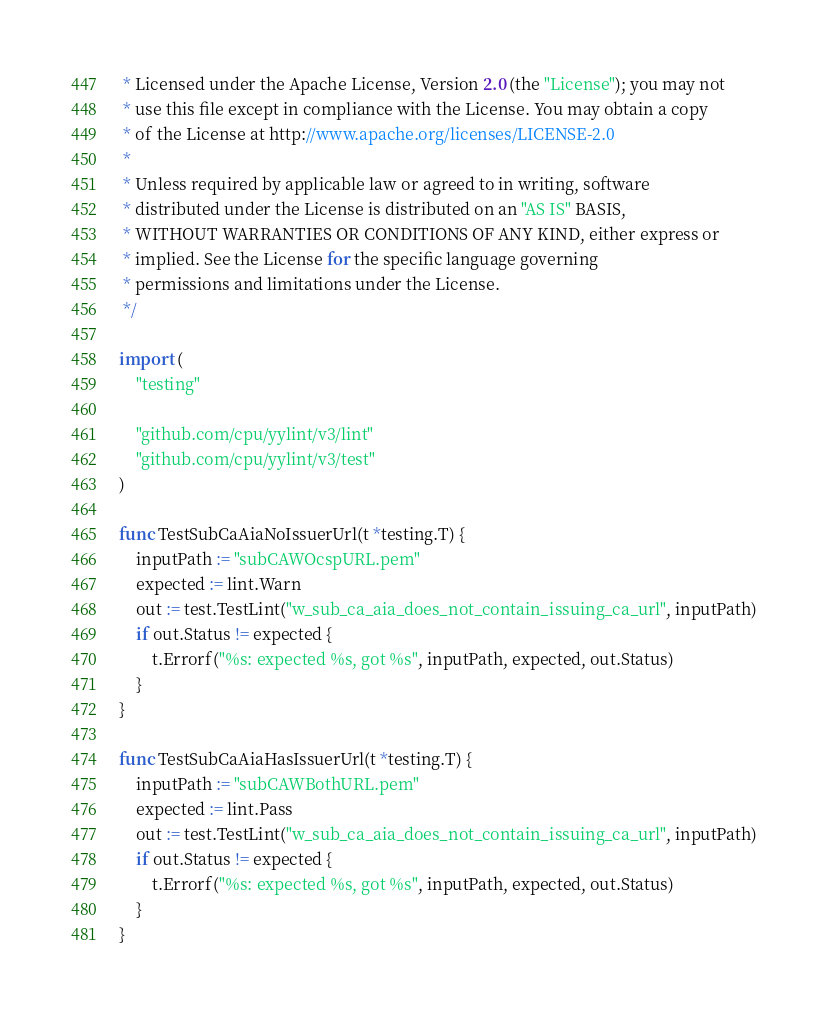<code> <loc_0><loc_0><loc_500><loc_500><_Go_> * Licensed under the Apache License, Version 2.0 (the "License"); you may not
 * use this file except in compliance with the License. You may obtain a copy
 * of the License at http://www.apache.org/licenses/LICENSE-2.0
 *
 * Unless required by applicable law or agreed to in writing, software
 * distributed under the License is distributed on an "AS IS" BASIS,
 * WITHOUT WARRANTIES OR CONDITIONS OF ANY KIND, either express or
 * implied. See the License for the specific language governing
 * permissions and limitations under the License.
 */

import (
	"testing"

	"github.com/cpu/yylint/v3/lint"
	"github.com/cpu/yylint/v3/test"
)

func TestSubCaAiaNoIssuerUrl(t *testing.T) {
	inputPath := "subCAWOcspURL.pem"
	expected := lint.Warn
	out := test.TestLint("w_sub_ca_aia_does_not_contain_issuing_ca_url", inputPath)
	if out.Status != expected {
		t.Errorf("%s: expected %s, got %s", inputPath, expected, out.Status)
	}
}

func TestSubCaAiaHasIssuerUrl(t *testing.T) {
	inputPath := "subCAWBothURL.pem"
	expected := lint.Pass
	out := test.TestLint("w_sub_ca_aia_does_not_contain_issuing_ca_url", inputPath)
	if out.Status != expected {
		t.Errorf("%s: expected %s, got %s", inputPath, expected, out.Status)
	}
}
</code> 